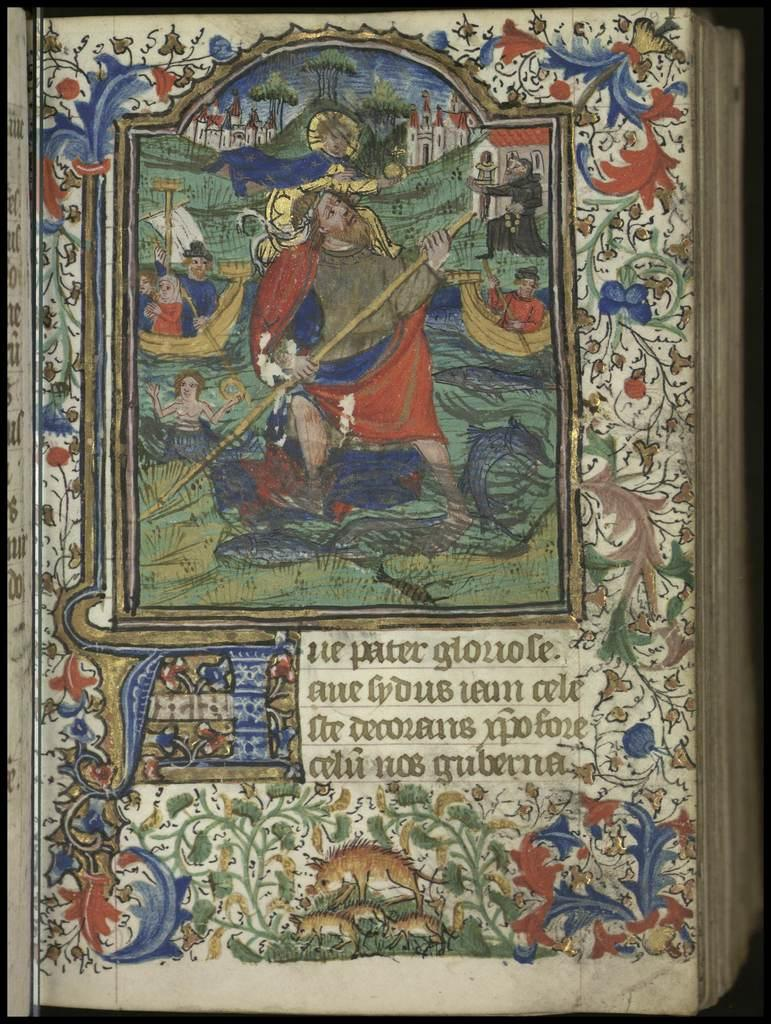<image>
Summarize the visual content of the image. A book with a drawing of people on boats and writing that starts "ue pater glouole". 